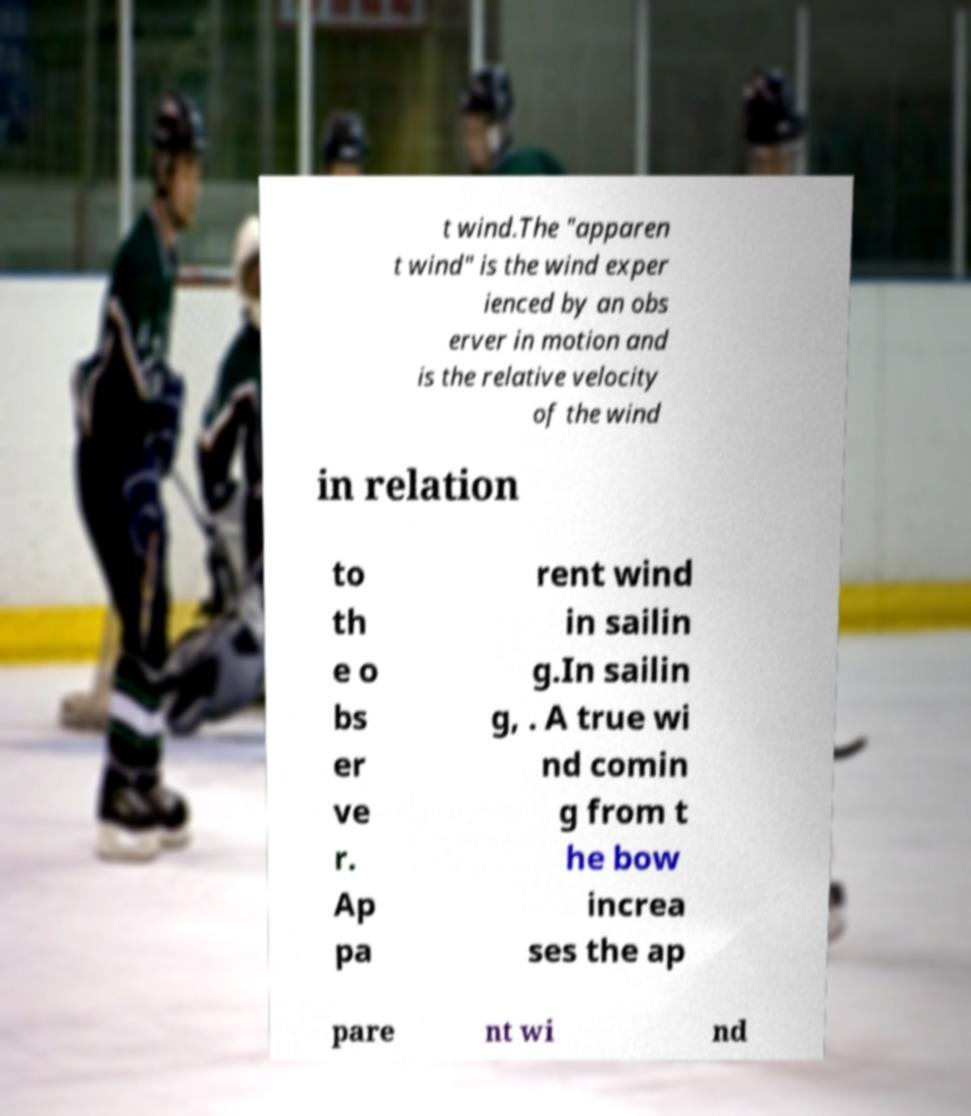Please identify and transcribe the text found in this image. t wind.The "apparen t wind" is the wind exper ienced by an obs erver in motion and is the relative velocity of the wind in relation to th e o bs er ve r. Ap pa rent wind in sailin g.In sailin g, . A true wi nd comin g from t he bow increa ses the ap pare nt wi nd 